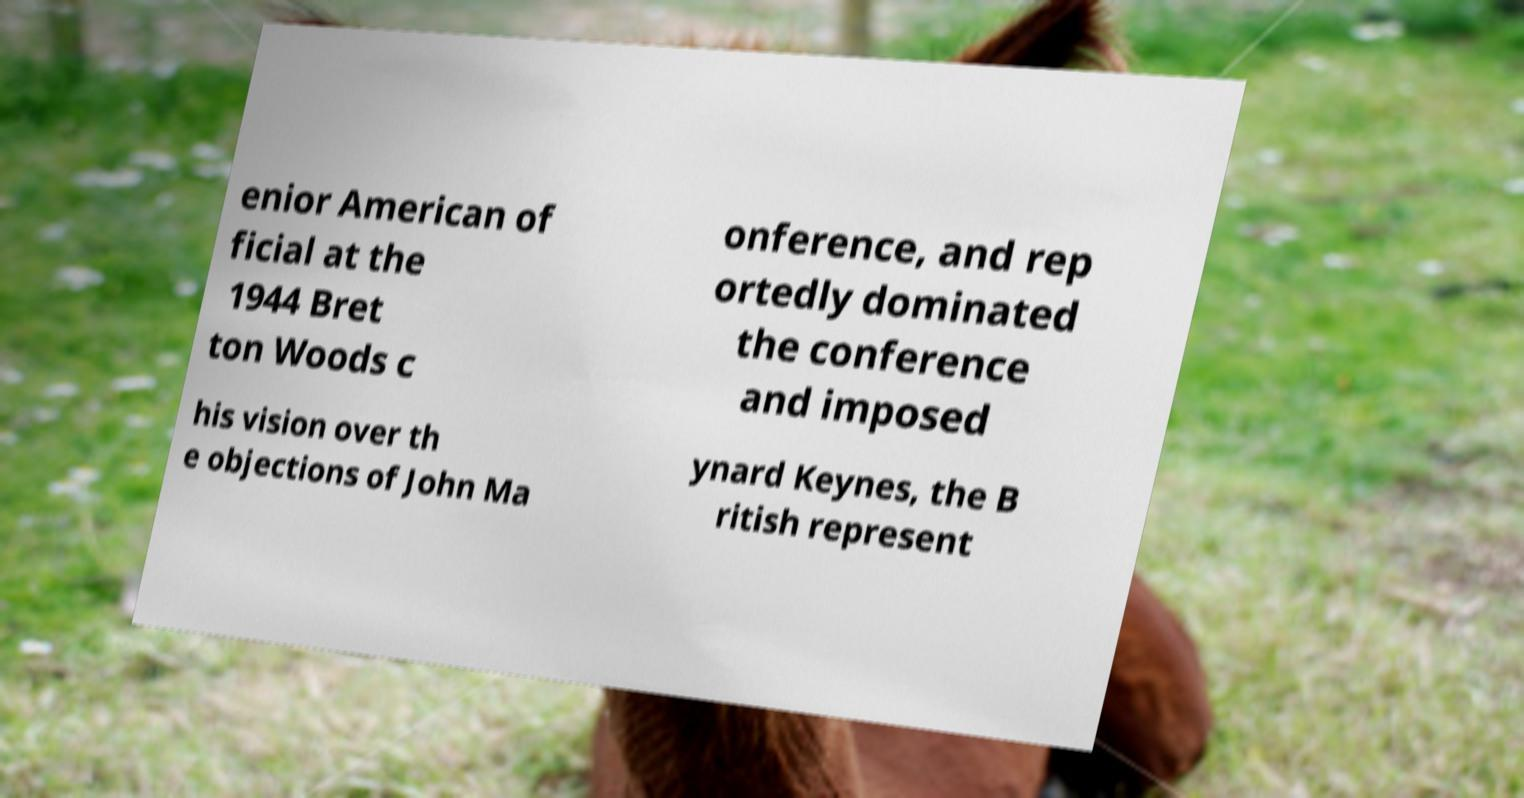Can you read and provide the text displayed in the image?This photo seems to have some interesting text. Can you extract and type it out for me? enior American of ficial at the 1944 Bret ton Woods c onference, and rep ortedly dominated the conference and imposed his vision over th e objections of John Ma ynard Keynes, the B ritish represent 